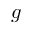Convert formula to latex. <formula><loc_0><loc_0><loc_500><loc_500>g</formula> 